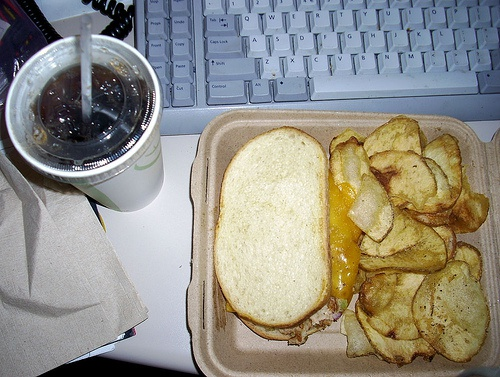Describe the objects in this image and their specific colors. I can see keyboard in black, darkgray, and gray tones, sandwich in black, beige, and olive tones, and cup in black, darkgray, gray, and white tones in this image. 